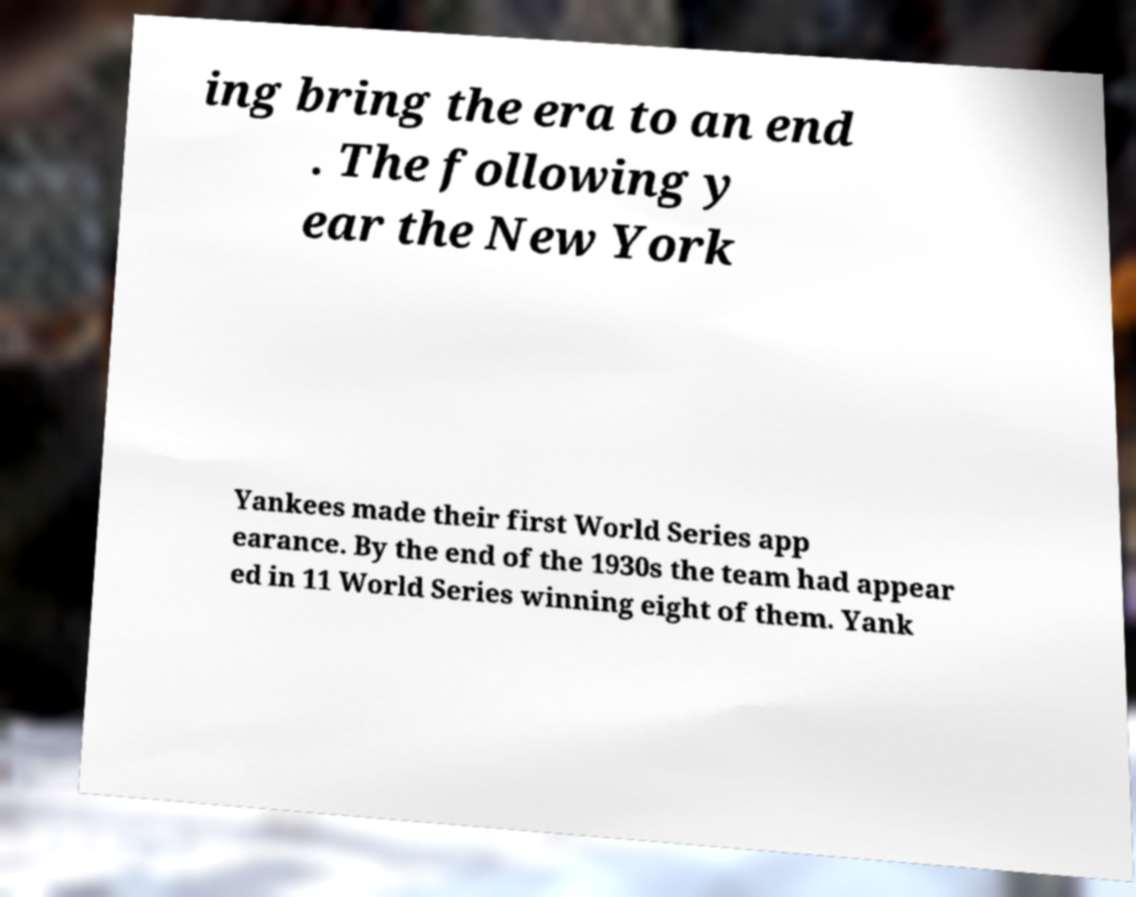What messages or text are displayed in this image? I need them in a readable, typed format. ing bring the era to an end . The following y ear the New York Yankees made their first World Series app earance. By the end of the 1930s the team had appear ed in 11 World Series winning eight of them. Yank 